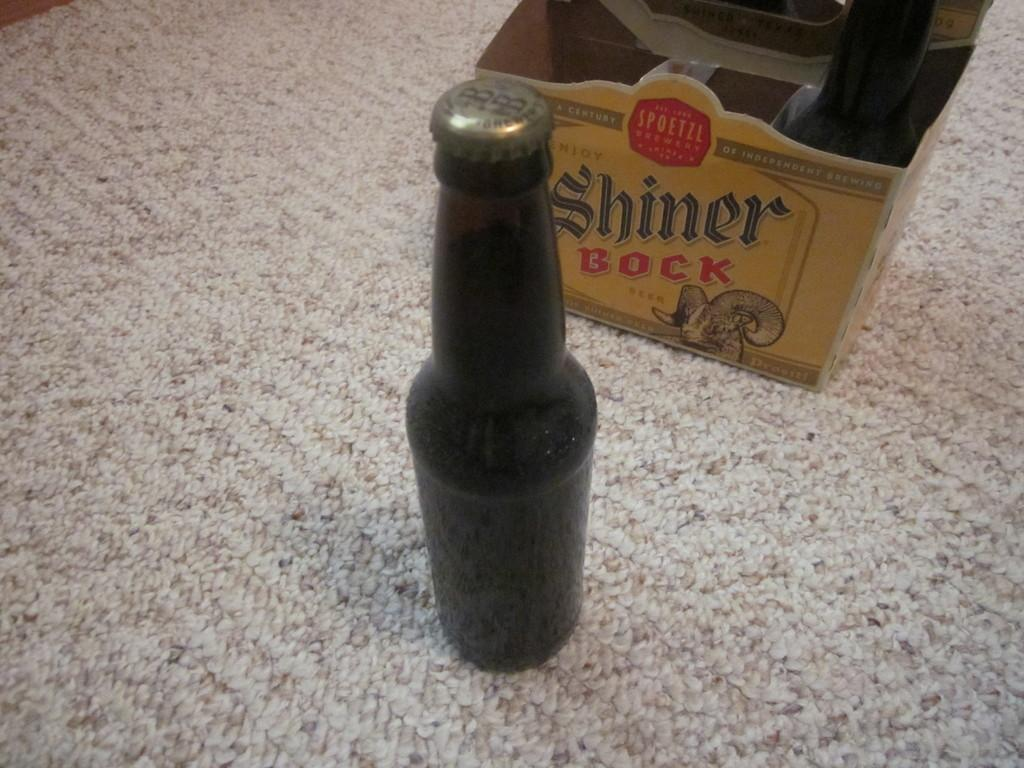<image>
Summarize the visual content of the image. A cardboard box with a beer still in it is named Shiner Bock. 